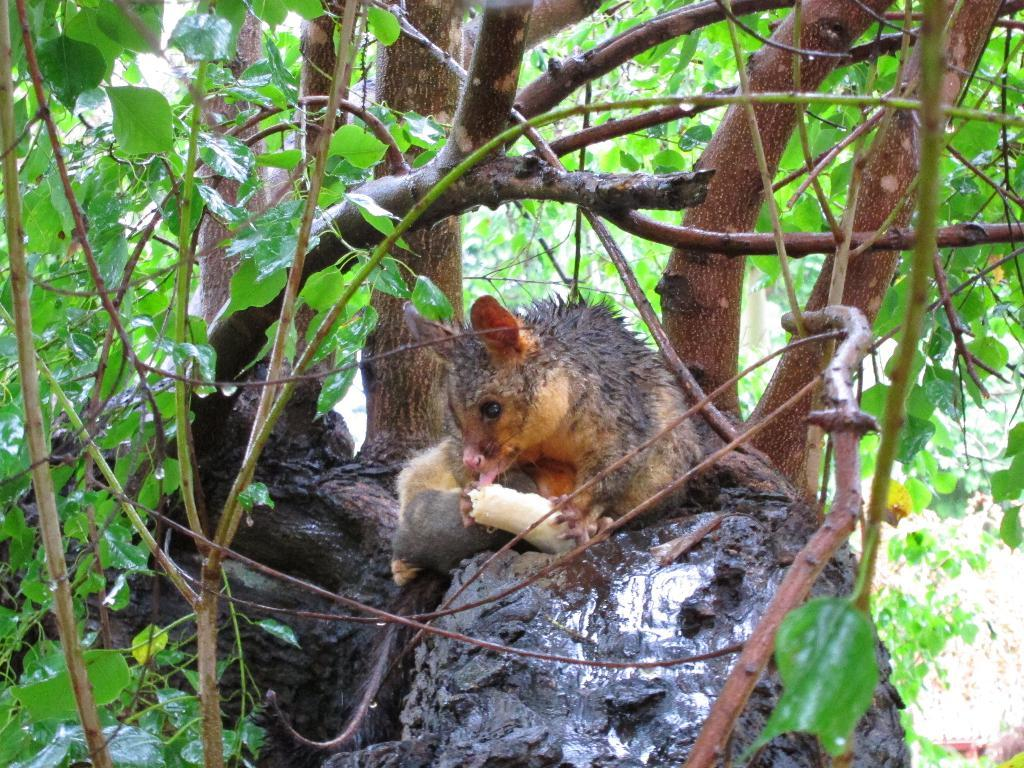What type of animal is in the image? There is a fox squirrel in the image. Where is the fox squirrel located? The fox squirrel is on a log. What other elements can be seen in the image? There are stems and leaves in the image. Is the fox squirrel driving a car in the image? No, the fox squirrel is not driving a car in the image; it is on a log. Can you see a camera in the image? No, there is no camera present in the image. 